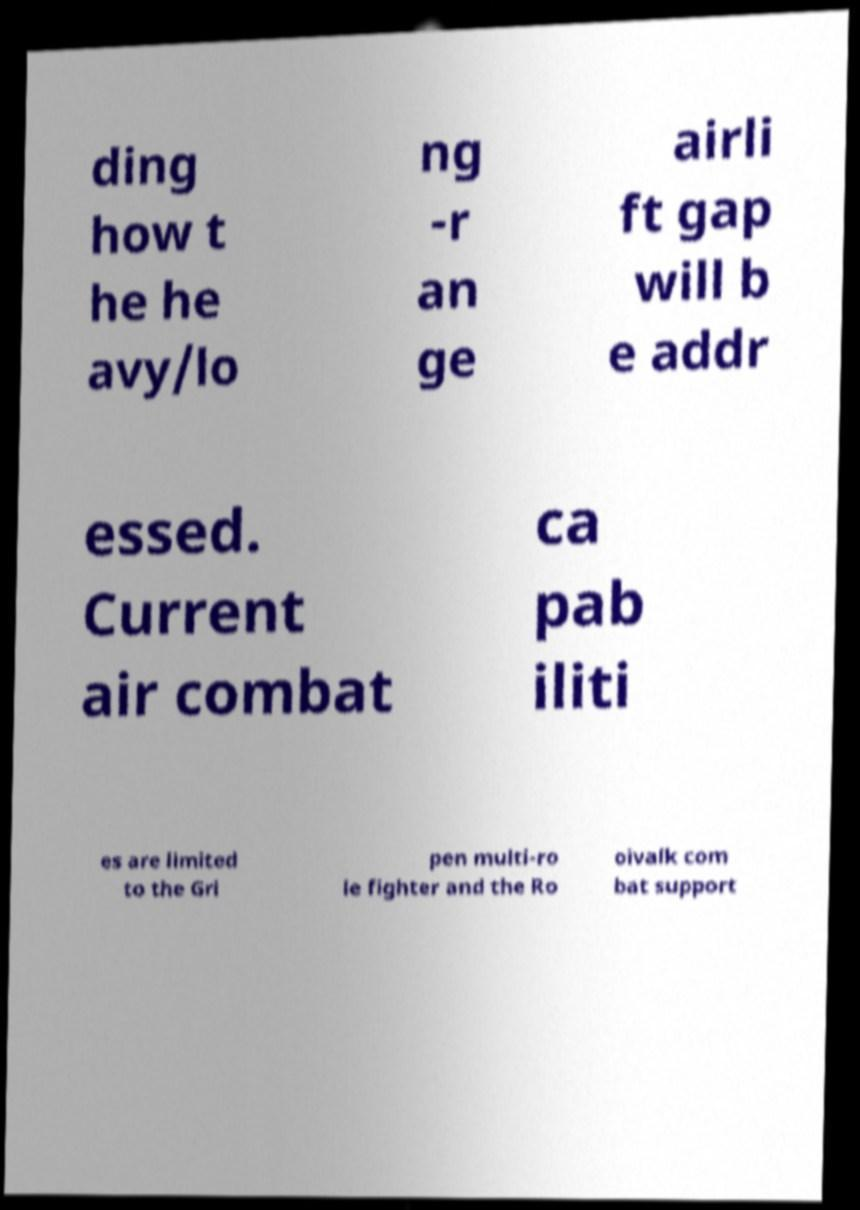For documentation purposes, I need the text within this image transcribed. Could you provide that? ding how t he he avy/lo ng -r an ge airli ft gap will b e addr essed. Current air combat ca pab iliti es are limited to the Gri pen multi-ro le fighter and the Ro oivalk com bat support 